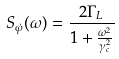Convert formula to latex. <formula><loc_0><loc_0><loc_500><loc_500>S _ { \dot { \varphi } } ( \omega ) = \frac { 2 \Gamma _ { L } } { 1 + \frac { \omega ^ { 2 } } { \gamma _ { c } ^ { 2 } } }</formula> 